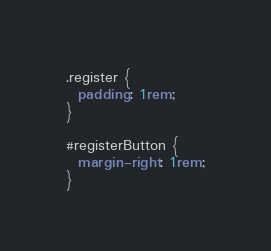<code> <loc_0><loc_0><loc_500><loc_500><_CSS_>.register {
  padding: 1rem;
}

#registerButton {
  margin-right: 1rem;
}
</code> 